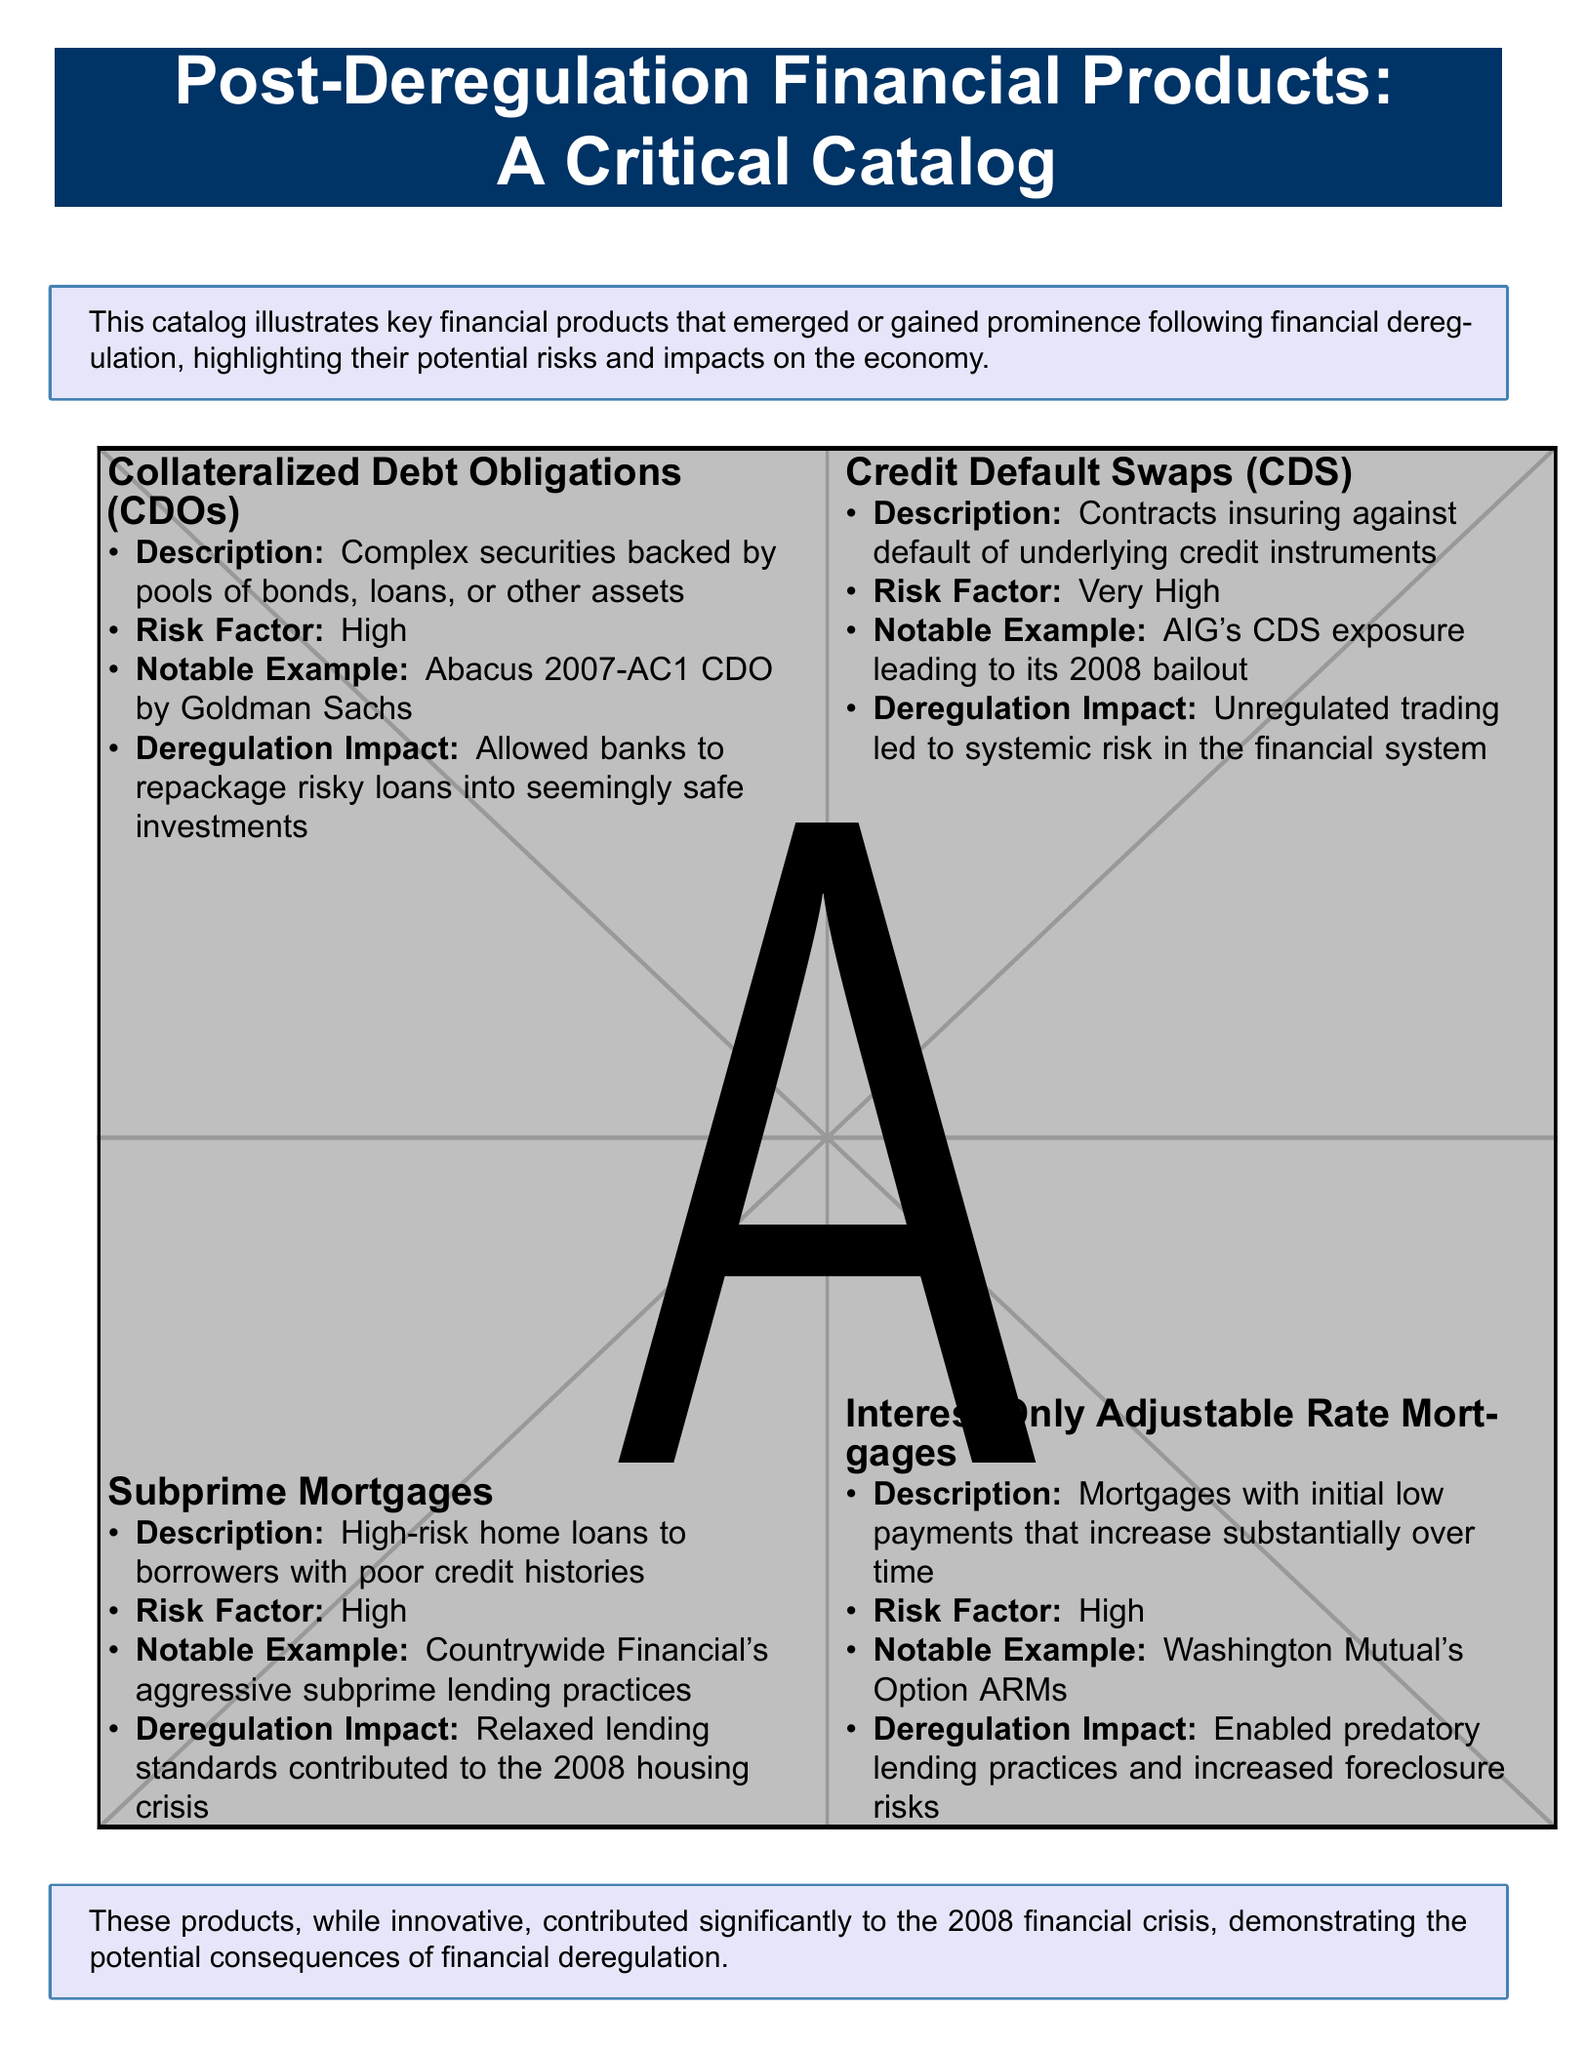What is the title of the catalog? The title is presented at the top of the document, highlighting the focus on financial products post-deregulation.
Answer: Post-Deregulation Financial Products: A Critical Catalog What is a notable example of a Collateralized Debt Obligation? The document lists specific examples for each financial product, pointing out one related to CDOs.
Answer: Abacus 2007-AC1 CDO by Goldman Sachs What is the risk factor associated with Credit Default Swaps? Each product includes a risk factor, categorized in the document.
Answer: Very High Which financial product is described as high-risk home loans? The catalog specifies different products; one is clearly defined as high-risk home loans.
Answer: Subprime Mortgages What is the deregulation impact noted for Interest-Only Adjustable Rate Mortgages? The impact is outlined to show the consequences of deregulation on certain financial practices.
Answer: Enabled predatory lending practices and increased foreclosure risks What was a notable example of subprime lending practices? The document provides a clear example of aggressive subprime lending related to a specific company.
Answer: Countrywide Financial's aggressive subprime lending practices What is the overall theme of the catalog? A key statement about the catalog reveals its purpose and central message regarding financial products.
Answer: Consequences of financial deregulation What does the catalog conclude about the financial products discussed? The conclusion summarizes the effects of the products on the financial landscape.
Answer: Contributed significantly to the 2008 financial crisis 